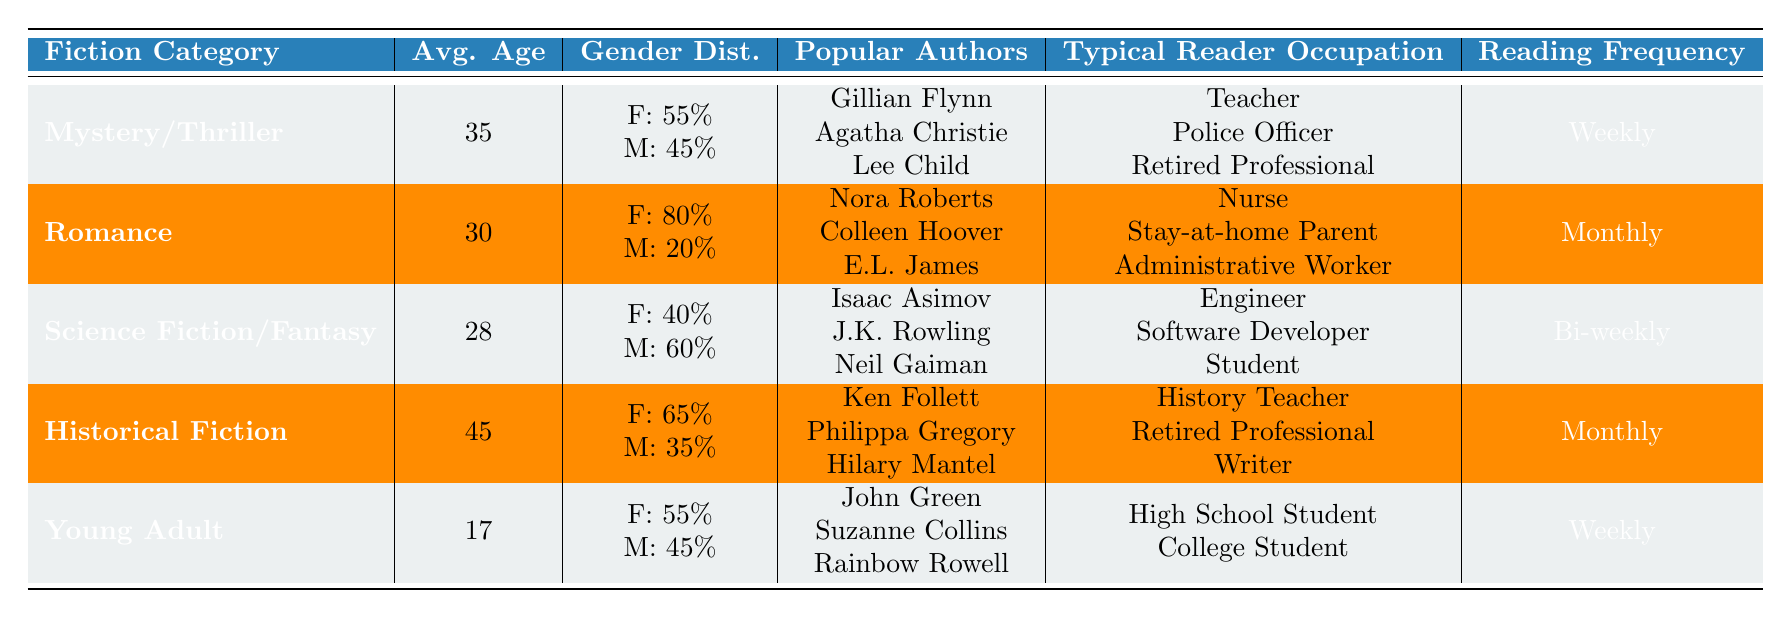What is the average age of readers in the Romance category? The table shows the average age of readers in the Romance category as 30.
Answer: 30 Which fiction category has the highest percentage of female readers? In the table, the category with the highest female percentage is Romance at 80%.
Answer: Romance What is the gender distribution for Science Fiction/Fantasy readers? The table indicates that for Science Fiction/Fantasy, the gender distribution is Female: 40% and Male: 60%.
Answer: Female: 40%, Male: 60% How many readers, on average, are older in Historical Fiction compared to Young Adult? The average age for Historical Fiction is 45 and for Young Adult is 17. The difference is 45 - 17 = 28 years older in Historical Fiction.
Answer: 28 years Do readers of Historical Fiction typically read weekly? The table states that Historical Fiction readers have a monthly reading frequency, which means they do not read weekly.
Answer: No Which occupation is typical for readers of Mystery/Thriller? Typical occupations for Mystery/Thriller readers are listed as Teacher, Police Officer, and Retired Professional.
Answer: Teacher, Police Officer, Retired Professional Calculate the average age of readers across all fiction categories. The average age is calculated using the ages from each category: (35 + 30 + 28 + 45 + 17) = 155; then divide by 5 (the number of categories) giving an average age of 31.
Answer: 31 Are there more male readers in Romance than in Mystery/Thriller? The gender distribution shows 20% male in Romance and 45% male in Mystery/Thriller, indicating there are more male readers in Mystery/Thriller.
Answer: No Which authors are popular among Young Adult readers? The table lists the popular authors for Young Adult as John Green, Suzanne Collins, and Rainbow Rowell.
Answer: John Green, Suzanne Collins, Rainbow Rowell 